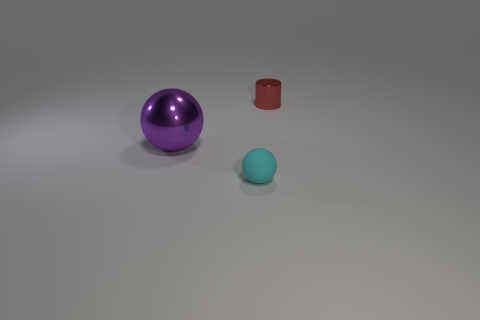What number of matte objects are either objects or small red cylinders?
Your response must be concise. 1. There is a small object in front of the metallic thing that is behind the sphere that is behind the tiny cyan ball; what is its material?
Your answer should be very brief. Rubber. There is a tiny object that is on the left side of the shiny cylinder; does it have the same shape as the small thing that is behind the big purple metallic sphere?
Provide a short and direct response. No. There is a small thing that is on the left side of the small thing behind the small matte object; what color is it?
Provide a short and direct response. Cyan. How many cubes are purple metallic objects or small shiny objects?
Offer a terse response. 0. What number of tiny red things are on the right side of the thing that is in front of the big purple thing to the left of the small matte sphere?
Offer a very short reply. 1. Is there a red thing made of the same material as the purple sphere?
Make the answer very short. Yes. Does the red thing have the same material as the small cyan sphere?
Your answer should be compact. No. There is a tiny object that is in front of the purple shiny sphere; what number of metallic objects are behind it?
Offer a very short reply. 2. What number of red objects are tiny metal cylinders or shiny things?
Offer a terse response. 1. 